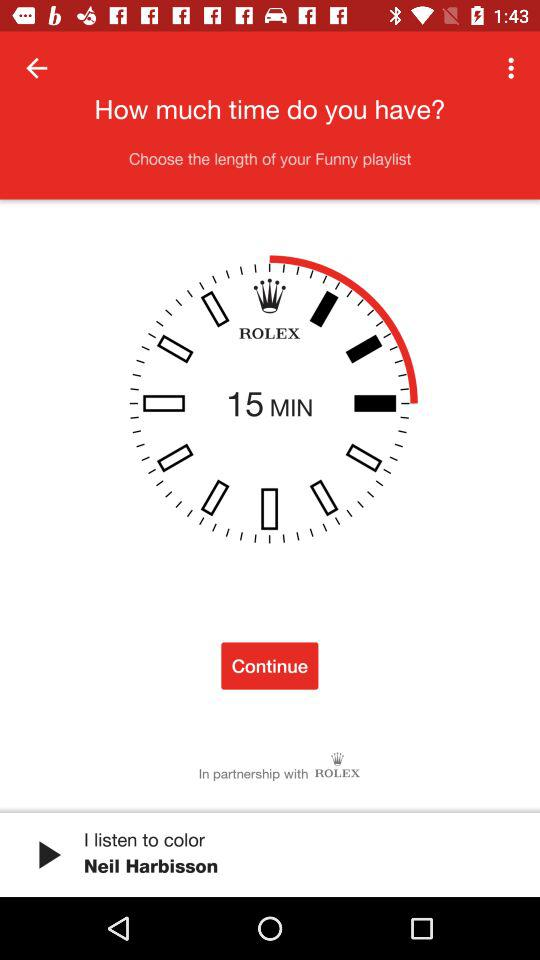What is the brand of the watch? The brand of the watch is "ROLEX". 